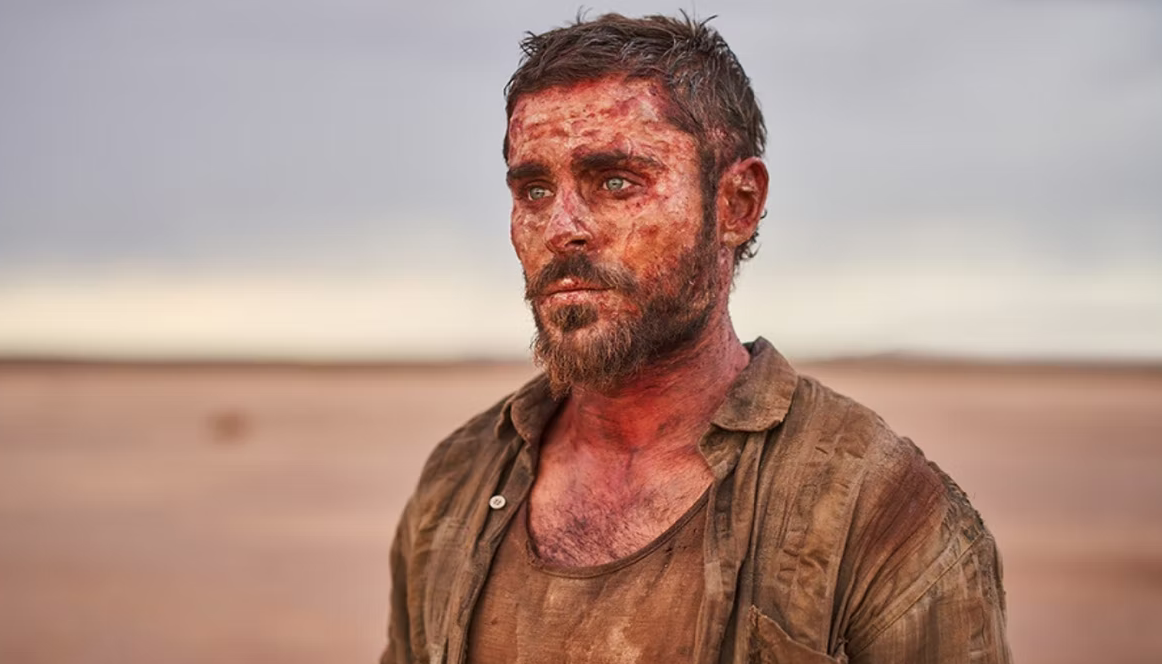Describe the possible storyline that led to this moment captured in the image. The image seems to capture a pivotal moment in a survival drama. The character, portrayed by the actor Zac Efron, appears to have been through an intense ordeal, possibly stranded in the desert. The story could revolve around a man who finds himself isolated in a harsh, unforgiving desert landscape after a plane crash or a vehicle breakdown. The dirt and blood on his face and clothes suggest he has faced not only the brutal elements but also physical confrontations or dangerous wildlife. His determination is evident despite the exhaustion, indicating his struggle towards survival, clinging to the hope of rescue or finding his way back to civilization. 